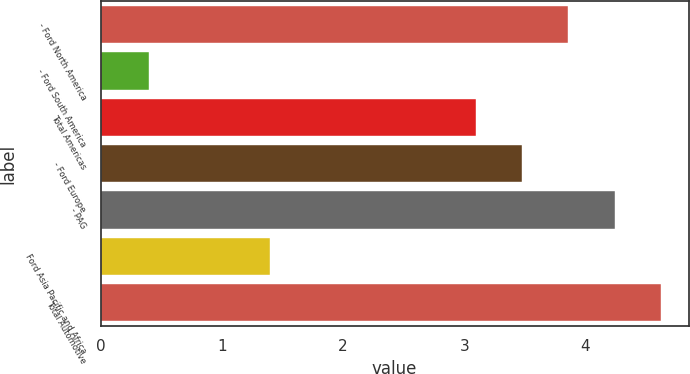Convert chart to OTSL. <chart><loc_0><loc_0><loc_500><loc_500><bar_chart><fcel>- Ford North America<fcel>- Ford South America<fcel>Total Americas<fcel>- Ford Europe<fcel>- PAG<fcel>Ford Asia Pacific and Africa<fcel>Total Automotive<nl><fcel>3.86<fcel>0.4<fcel>3.1<fcel>3.48<fcel>4.24<fcel>1.4<fcel>4.62<nl></chart> 